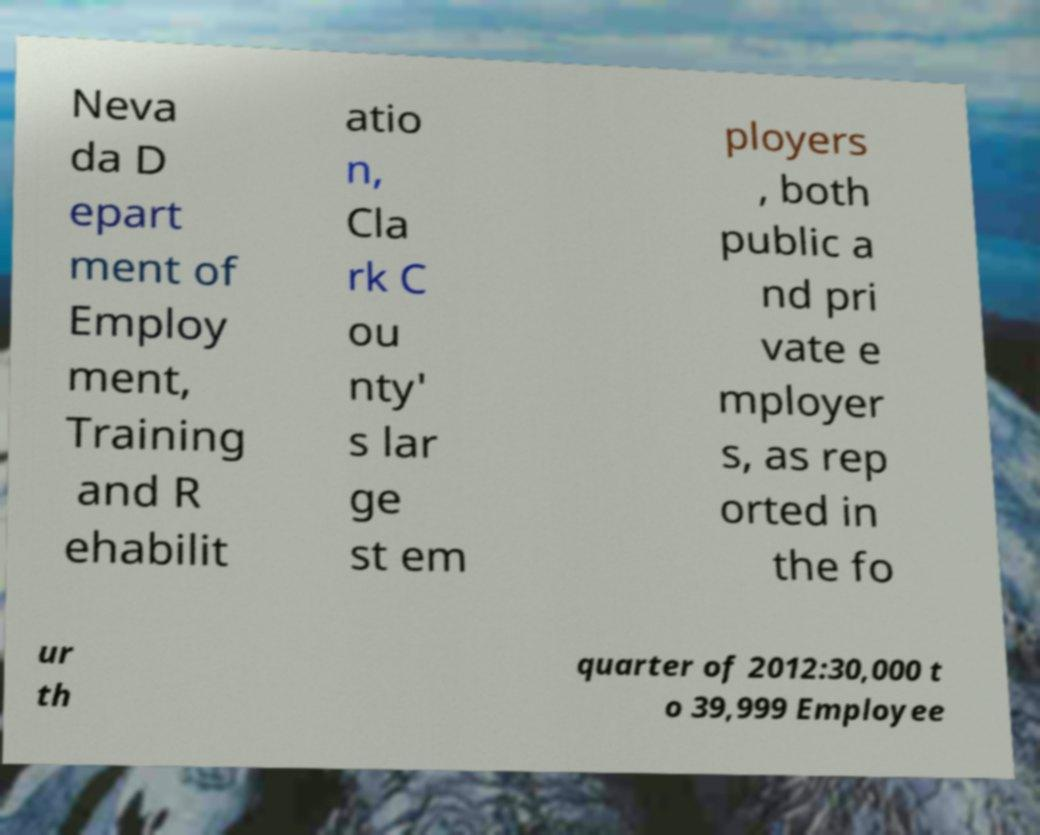I need the written content from this picture converted into text. Can you do that? Neva da D epart ment of Employ ment, Training and R ehabilit atio n, Cla rk C ou nty' s lar ge st em ployers , both public a nd pri vate e mployer s, as rep orted in the fo ur th quarter of 2012:30,000 t o 39,999 Employee 